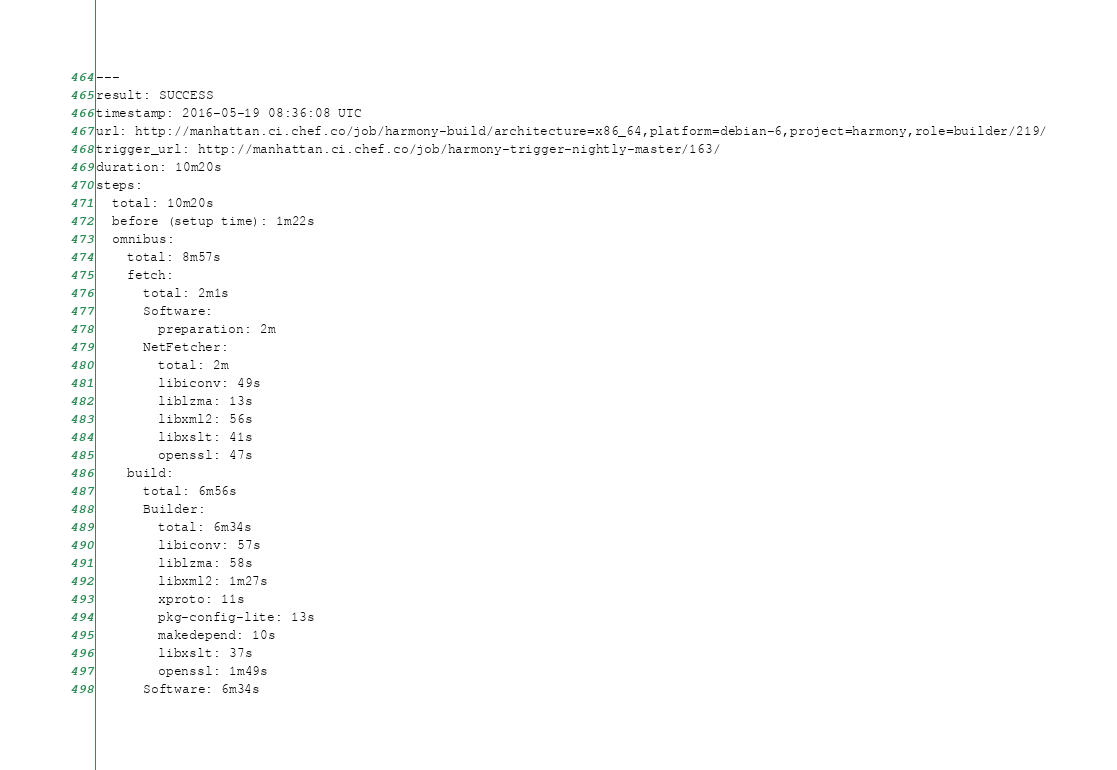Convert code to text. <code><loc_0><loc_0><loc_500><loc_500><_YAML_>---
result: SUCCESS
timestamp: 2016-05-19 08:36:08 UTC
url: http://manhattan.ci.chef.co/job/harmony-build/architecture=x86_64,platform=debian-6,project=harmony,role=builder/219/
trigger_url: http://manhattan.ci.chef.co/job/harmony-trigger-nightly-master/163/
duration: 10m20s
steps:
  total: 10m20s
  before (setup time): 1m22s
  omnibus:
    total: 8m57s
    fetch:
      total: 2m1s
      Software:
        preparation: 2m
      NetFetcher:
        total: 2m
        libiconv: 49s
        liblzma: 13s
        libxml2: 56s
        libxslt: 41s
        openssl: 47s
    build:
      total: 6m56s
      Builder:
        total: 6m34s
        libiconv: 57s
        liblzma: 58s
        libxml2: 1m27s
        xproto: 11s
        pkg-config-lite: 13s
        makedepend: 10s
        libxslt: 37s
        openssl: 1m49s
      Software: 6m34s</code> 